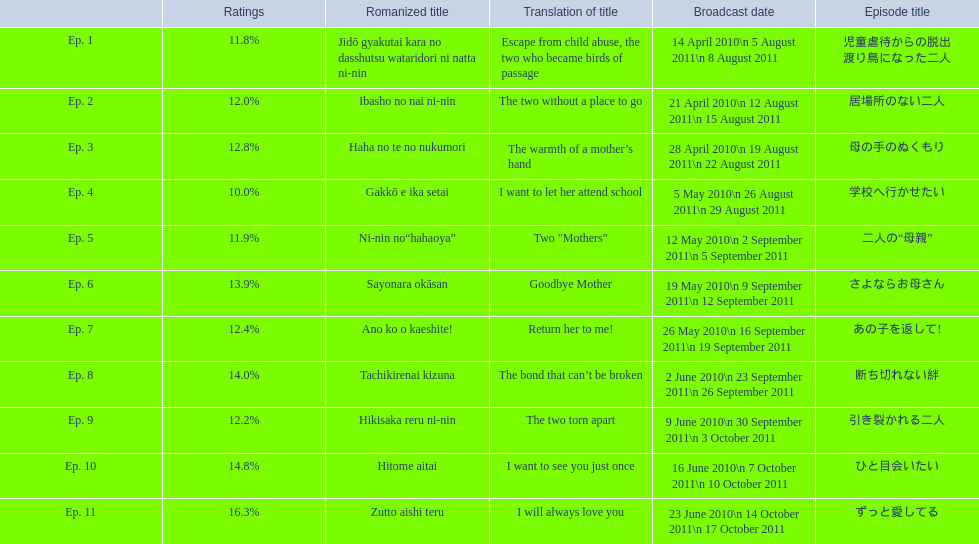What were all the episode titles for the show mother? 児童虐待からの脱出 渡り鳥になった二人, 居場所のない二人, 母の手のぬくもり, 学校へ行かせたい, 二人の“母親”, さよならお母さん, あの子を返して!, 断ち切れない絆, 引き裂かれる二人, ひと目会いたい, ずっと愛してる. What were all the translated episode titles for the show mother? Escape from child abuse, the two who became birds of passage, The two without a place to go, The warmth of a mother’s hand, I want to let her attend school, Two "Mothers", Goodbye Mother, Return her to me!, The bond that can’t be broken, The two torn apart, I want to see you just once, I will always love you. Which episode was translated to i want to let her attend school? Ep. 4. 